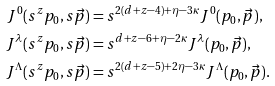Convert formula to latex. <formula><loc_0><loc_0><loc_500><loc_500>J ^ { 0 } ( s ^ { z } p _ { 0 } , s \vec { p } ) & = s ^ { 2 ( d + z - 4 ) + \eta - 3 \kappa } J ^ { 0 } ( p _ { 0 } , \vec { p } ) , \\ J ^ { \lambda } ( s ^ { z } p _ { 0 } , s \vec { p } ) & = s ^ { d + z - 6 + \eta - 2 \kappa } J ^ { \lambda } ( p _ { 0 } , \vec { p } ) , \\ J ^ { \Lambda } ( s ^ { z } p _ { 0 } , s \vec { p } ) & = s ^ { 2 ( d + z - 5 ) + 2 \eta - 3 \kappa } J ^ { \Lambda } ( p _ { 0 } , \vec { p } ) .</formula> 